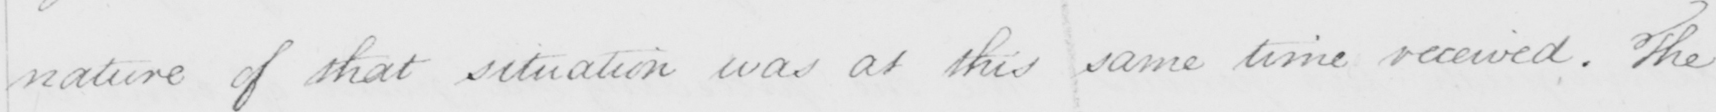Can you tell me what this handwritten text says? nature of the situation was at this same time received . The 